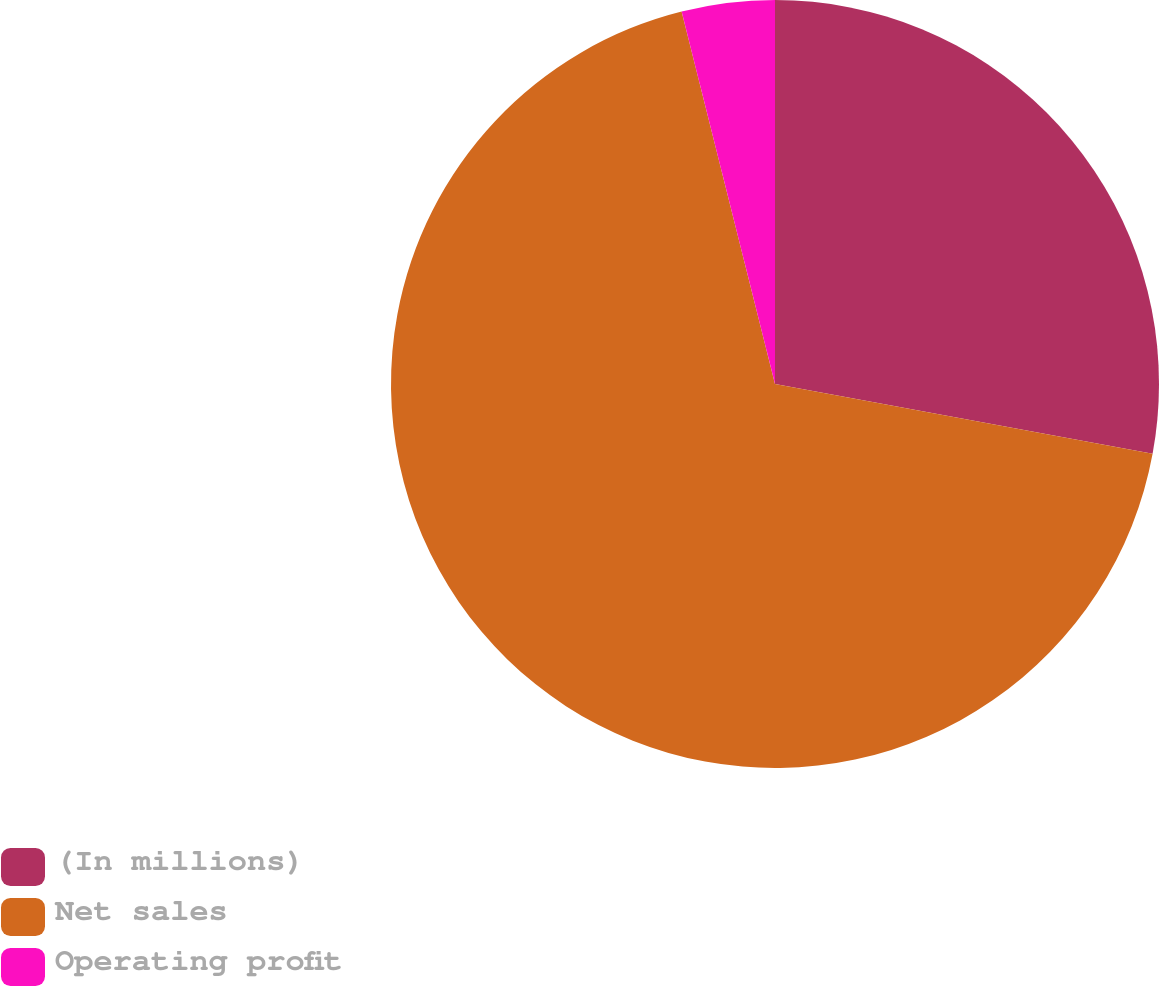Convert chart. <chart><loc_0><loc_0><loc_500><loc_500><pie_chart><fcel>(In millions)<fcel>Net sales<fcel>Operating profit<nl><fcel>27.91%<fcel>68.18%<fcel>3.91%<nl></chart> 